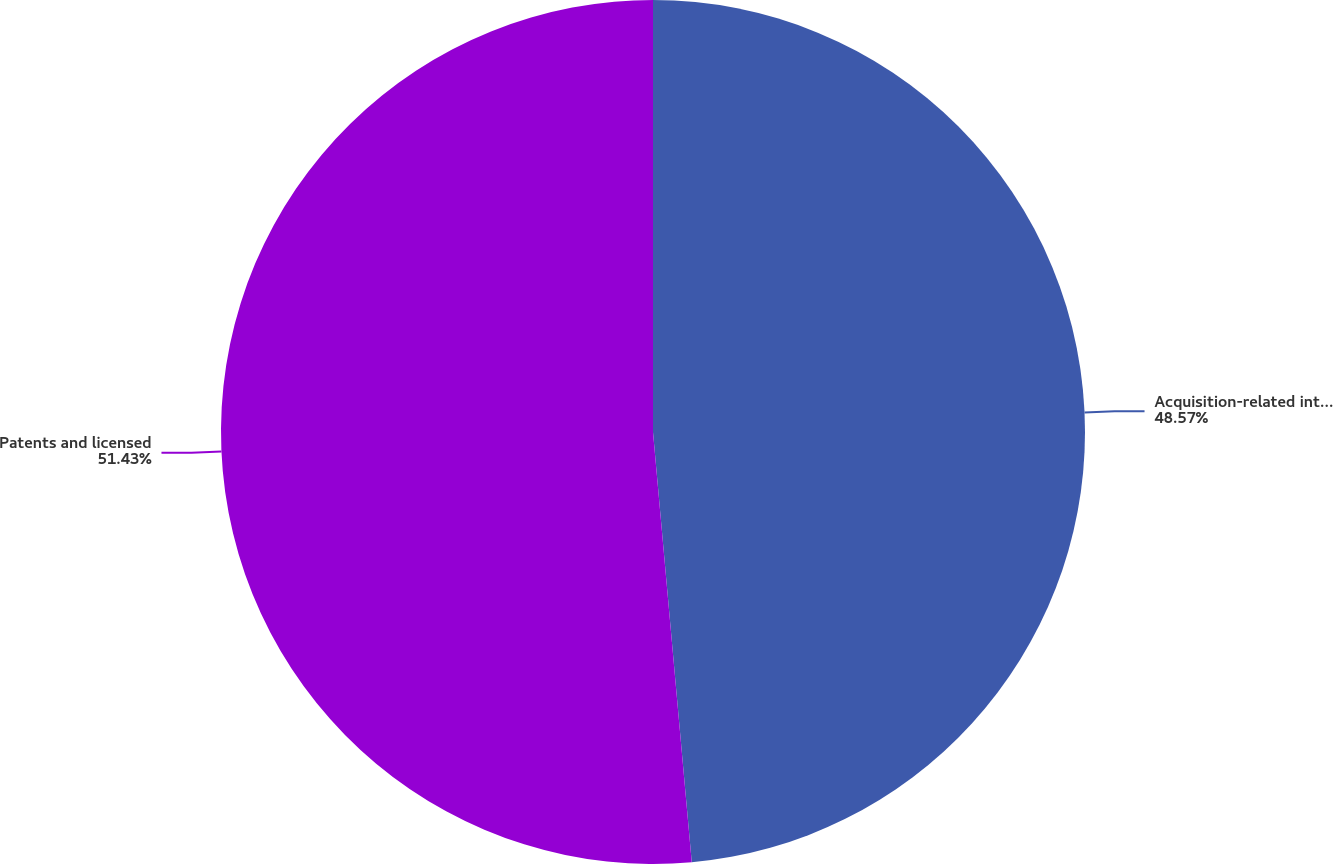Convert chart to OTSL. <chart><loc_0><loc_0><loc_500><loc_500><pie_chart><fcel>Acquisition-related intangible<fcel>Patents and licensed<nl><fcel>48.57%<fcel>51.43%<nl></chart> 